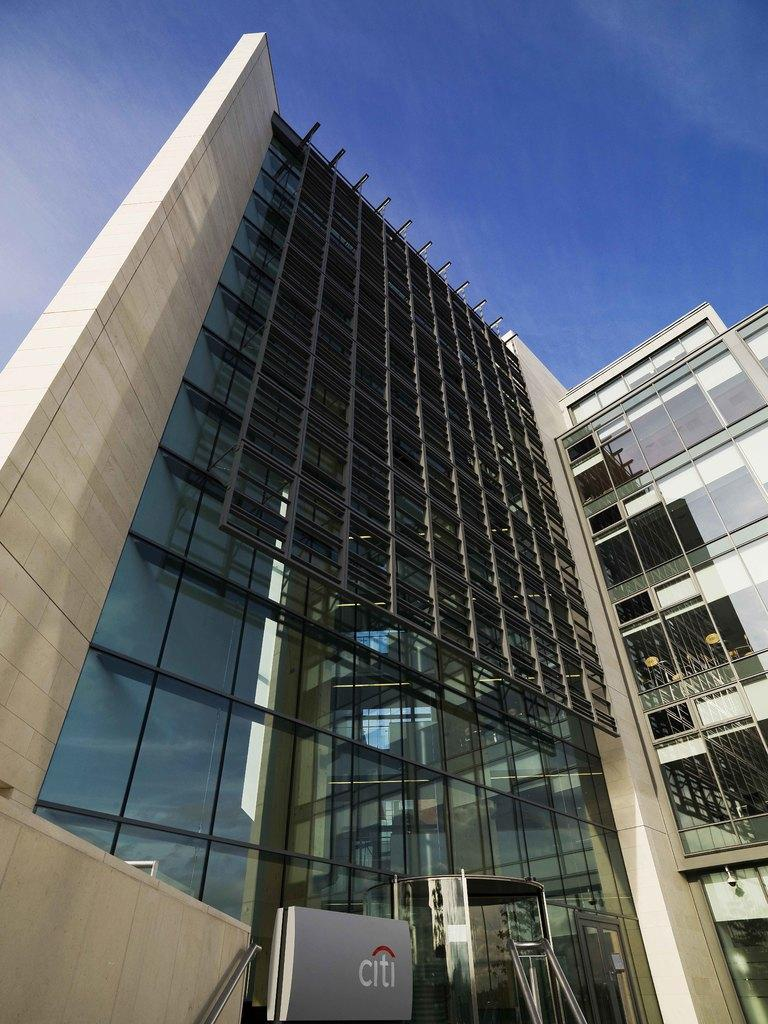What is the main subject in the center of the image? There is a building in the center of the image. Is there any additional information about the building? Yes, there is a board associated with the building. What can be seen in the background of the image? The sky is visible at the top of the image. How many snakes can be seen slithering around the building in the image? There are no snakes present in the image; it only features a building and a board. 